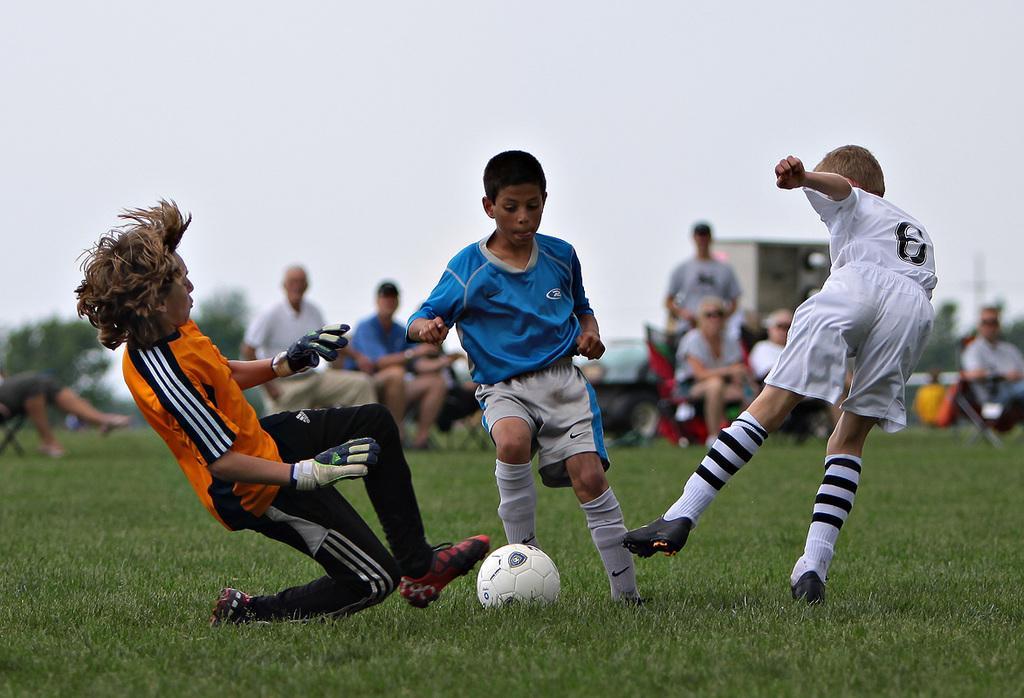Can you describe this image briefly? This picture shows three boys playing football all on the green field and we see few people seated and watching and we see a Man standing and watching them 